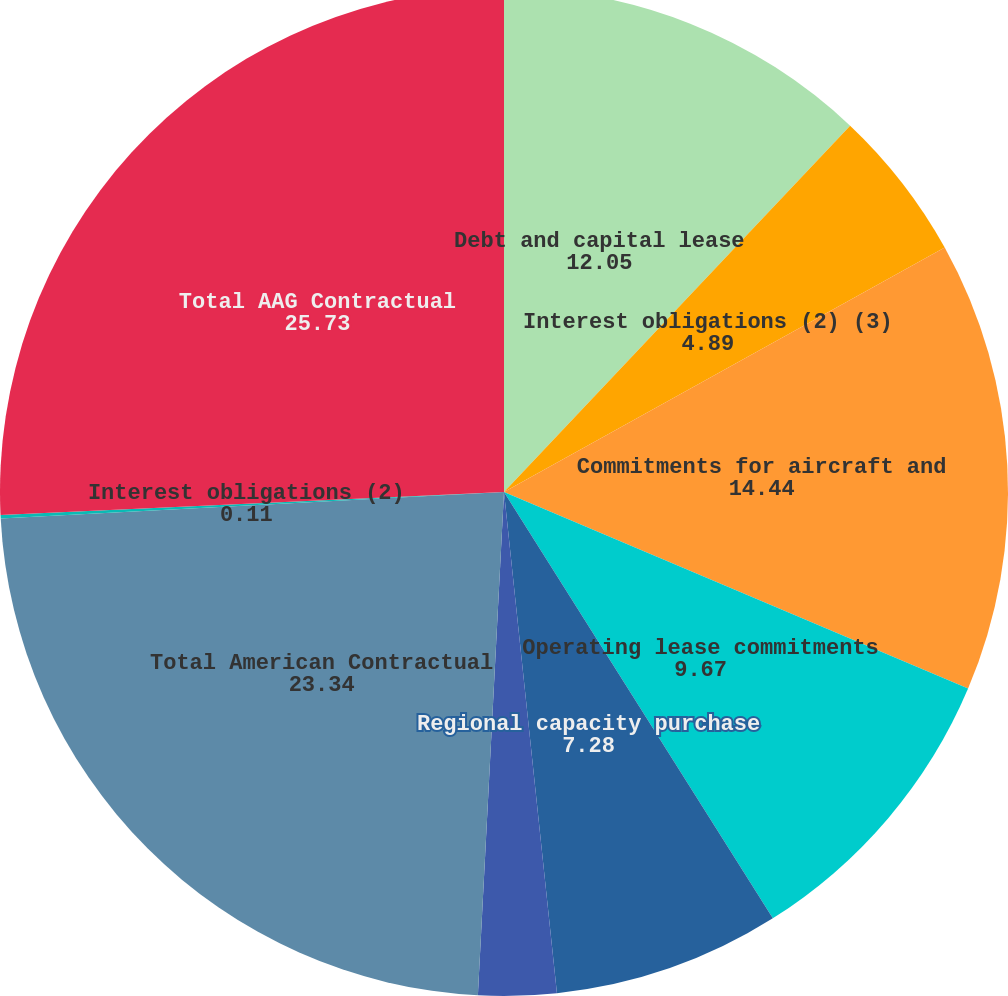Convert chart to OTSL. <chart><loc_0><loc_0><loc_500><loc_500><pie_chart><fcel>Debt and capital lease<fcel>Interest obligations (2) (3)<fcel>Commitments for aircraft and<fcel>Operating lease commitments<fcel>Regional capacity purchase<fcel>Retiree medical and other<fcel>Total American Contractual<fcel>Interest obligations (2)<fcel>Total AAG Contractual<nl><fcel>12.05%<fcel>4.89%<fcel>14.44%<fcel>9.67%<fcel>7.28%<fcel>2.5%<fcel>23.34%<fcel>0.11%<fcel>25.73%<nl></chart> 